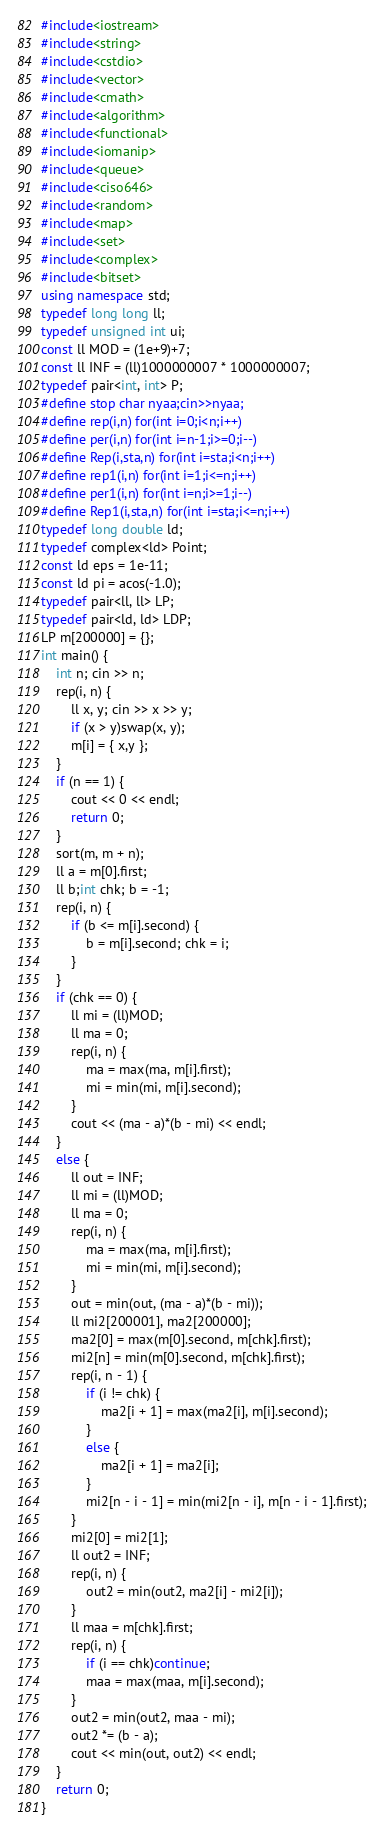<code> <loc_0><loc_0><loc_500><loc_500><_C++_>#include<iostream>
#include<string>
#include<cstdio>
#include<vector>
#include<cmath>
#include<algorithm>
#include<functional>
#include<iomanip>
#include<queue>
#include<ciso646>
#include<random>
#include<map>
#include<set>
#include<complex>
#include<bitset>
using namespace std;
typedef long long ll;
typedef unsigned int ui;
const ll MOD = (1e+9)+7;
const ll INF = (ll)1000000007 * 1000000007;
typedef pair<int, int> P;
#define stop char nyaa;cin>>nyaa;
#define rep(i,n) for(int i=0;i<n;i++)
#define per(i,n) for(int i=n-1;i>=0;i--)
#define Rep(i,sta,n) for(int i=sta;i<n;i++)
#define rep1(i,n) for(int i=1;i<=n;i++)
#define per1(i,n) for(int i=n;i>=1;i--)
#define Rep1(i,sta,n) for(int i=sta;i<=n;i++)
typedef long double ld;
typedef complex<ld> Point;
const ld eps = 1e-11;
const ld pi = acos(-1.0);
typedef pair<ll, ll> LP;
typedef pair<ld, ld> LDP;
LP m[200000] = {};
int main() {
	int n; cin >> n;
	rep(i, n) {
		ll x, y; cin >> x >> y;
		if (x > y)swap(x, y);
		m[i] = { x,y };
	}
	if (n == 1) {
		cout << 0 << endl;
		return 0;
	}
	sort(m, m + n);
	ll a = m[0].first;
	ll b;int chk; b = -1;
	rep(i, n) {
		if (b <= m[i].second) {
			b = m[i].second; chk = i;
		}
	}
	if (chk == 0) {
		ll mi = (ll)MOD;
		ll ma = 0;
		rep(i, n) {
			ma = max(ma, m[i].first);
			mi = min(mi, m[i].second);
		}
		cout << (ma - a)*(b - mi) << endl;
	}
	else {
		ll out = INF;
		ll mi = (ll)MOD;
		ll ma = 0;
		rep(i, n) {
			ma = max(ma, m[i].first);
			mi = min(mi, m[i].second);
		}
		out = min(out, (ma - a)*(b - mi));
		ll mi2[200001], ma2[200000];
		ma2[0] = max(m[0].second, m[chk].first);
		mi2[n] = min(m[0].second, m[chk].first);
		rep(i, n - 1) {
			if (i != chk) {
				ma2[i + 1] = max(ma2[i], m[i].second);
			}
			else {
				ma2[i + 1] = ma2[i];
			}
			mi2[n - i - 1] = min(mi2[n - i], m[n - i - 1].first);
		}
		mi2[0] = mi2[1];
		ll out2 = INF;
		rep(i, n) {
			out2 = min(out2, ma2[i] - mi2[i]);
		}
		ll maa = m[chk].first;
		rep(i, n) {
			if (i == chk)continue;
			maa = max(maa, m[i].second);
		}
		out2 = min(out2, maa - mi);
		out2 *= (b - a);
		cout << min(out, out2) << endl;
	}
	return 0;
}</code> 